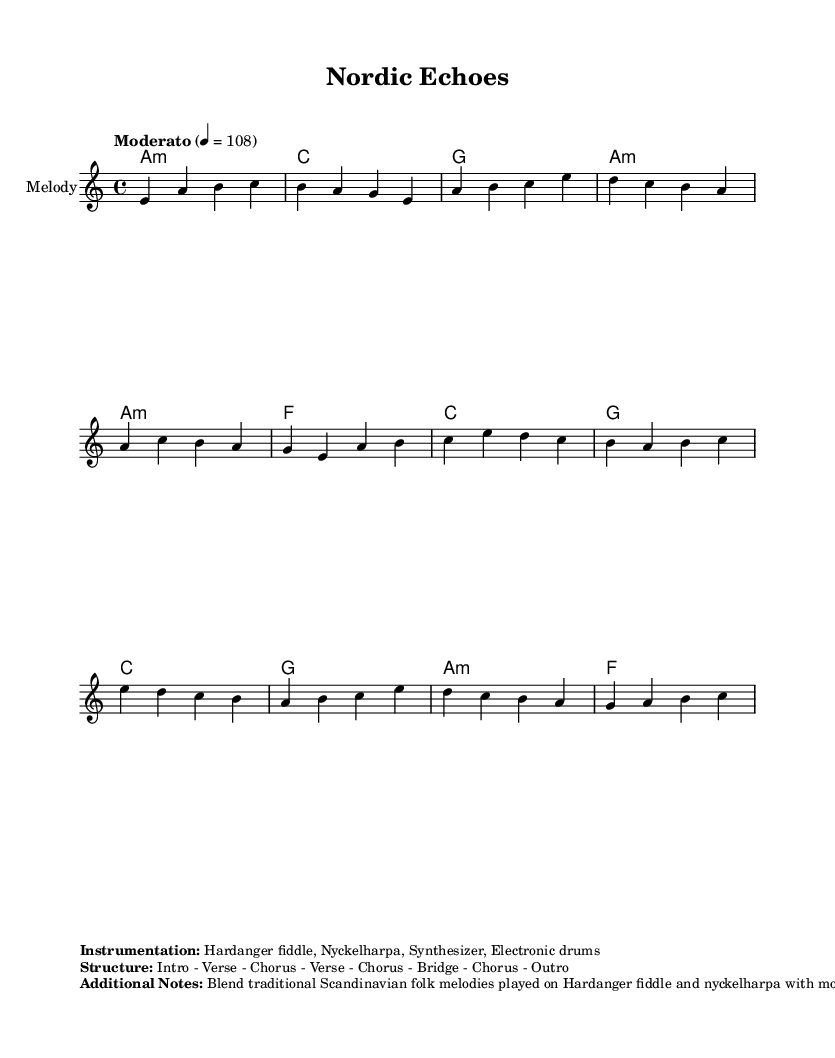What is the key signature of this music? The key signature is A minor, which has no sharps or flats but indicates the use of the notes A, B, C, D, E, F, and G.
Answer: A minor What is the time signature of this music? The time signature is 4/4, meaning there are four beats in each measure and the quarter note receives one beat.
Answer: 4/4 What is the tempo marking for this piece? The tempo marking is Moderato, which indicates a moderate speed typically ranging from 98 to 108 beats per minute.
Answer: Moderato How many sections are there in the structure of the piece? The structure includes eight sections: Intro, Verse, Chorus, Verse, Chorus, Bridge, Chorus, and Outro.
Answer: Eight What kind of instruments are used in this composition? The instruments listed are Hardanger fiddle, Nyckelharpa, Synthesizer, and Electronic drums, reflecting a blend of traditional and modern elements.
Answer: Hardanger fiddle, Nyckelharpa, Synthesizer, Electronic drums Which musical elements are combined to create the fusion sound? The fusion sound is created by blending traditional Scandinavian folk melodies with modern synthesizer arpeggios and electronic drum patterns, along with electronic effects like reverb and delay.
Answer: Traditional melodies, synthesizer arpeggios, electronic drum patterns What is the main chord used in the intro section? The main chord used in the intro section is A minor, indicated by the chord symbol that appears at the start of the piece.
Answer: A minor 